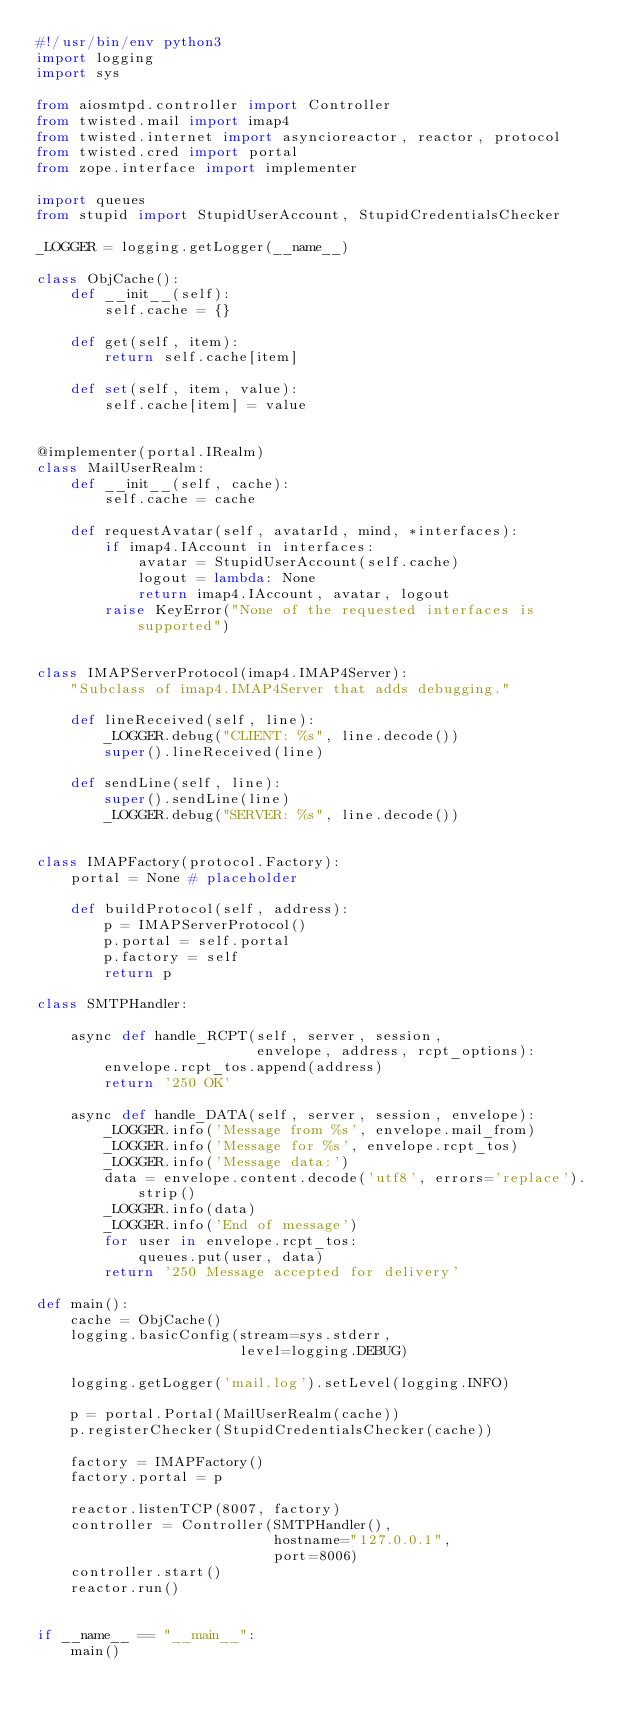Convert code to text. <code><loc_0><loc_0><loc_500><loc_500><_Python_>#!/usr/bin/env python3
import logging
import sys

from aiosmtpd.controller import Controller
from twisted.mail import imap4
from twisted.internet import asyncioreactor, reactor, protocol
from twisted.cred import portal
from zope.interface import implementer

import queues
from stupid import StupidUserAccount, StupidCredentialsChecker

_LOGGER = logging.getLogger(__name__)

class ObjCache():
    def __init__(self):
        self.cache = {}

    def get(self, item):
        return self.cache[item]

    def set(self, item, value):
        self.cache[item] = value


@implementer(portal.IRealm)
class MailUserRealm:
    def __init__(self, cache):
        self.cache = cache

    def requestAvatar(self, avatarId, mind, *interfaces):
        if imap4.IAccount in interfaces:
            avatar = StupidUserAccount(self.cache)
            logout = lambda: None
            return imap4.IAccount, avatar, logout
        raise KeyError("None of the requested interfaces is supported")


class IMAPServerProtocol(imap4.IMAP4Server):
    "Subclass of imap4.IMAP4Server that adds debugging."

    def lineReceived(self, line):
        _LOGGER.debug("CLIENT: %s", line.decode())
        super().lineReceived(line)

    def sendLine(self, line):
        super().sendLine(line)
        _LOGGER.debug("SERVER: %s", line.decode())


class IMAPFactory(protocol.Factory):
    portal = None # placeholder

    def buildProtocol(self, address):
        p = IMAPServerProtocol()
        p.portal = self.portal
        p.factory = self
        return p

class SMTPHandler:
    
    async def handle_RCPT(self, server, session,
                          envelope, address, rcpt_options):
        envelope.rcpt_tos.append(address)
        return '250 OK'

    async def handle_DATA(self, server, session, envelope):
        _LOGGER.info('Message from %s', envelope.mail_from)
        _LOGGER.info('Message for %s', envelope.rcpt_tos)
        _LOGGER.info('Message data:')
        data = envelope.content.decode('utf8', errors='replace').strip()
        _LOGGER.info(data)
        _LOGGER.info('End of message')
        for user in envelope.rcpt_tos:
            queues.put(user, data)
        return '250 Message accepted for delivery'

def main():
    cache = ObjCache()
    logging.basicConfig(stream=sys.stderr,
                        level=logging.DEBUG)

    logging.getLogger('mail.log').setLevel(logging.INFO)

    p = portal.Portal(MailUserRealm(cache))
    p.registerChecker(StupidCredentialsChecker(cache))

    factory = IMAPFactory()
    factory.portal = p

    reactor.listenTCP(8007, factory)
    controller = Controller(SMTPHandler(),
                            hostname="127.0.0.1",
                            port=8006)
    controller.start()
    reactor.run()


if __name__ == "__main__":
    main()
</code> 